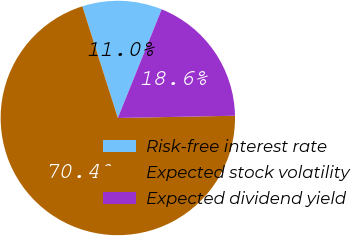Convert chart. <chart><loc_0><loc_0><loc_500><loc_500><pie_chart><fcel>Risk-free interest rate<fcel>Expected stock volatility<fcel>Expected dividend yield<nl><fcel>11.0%<fcel>70.41%<fcel>18.59%<nl></chart> 